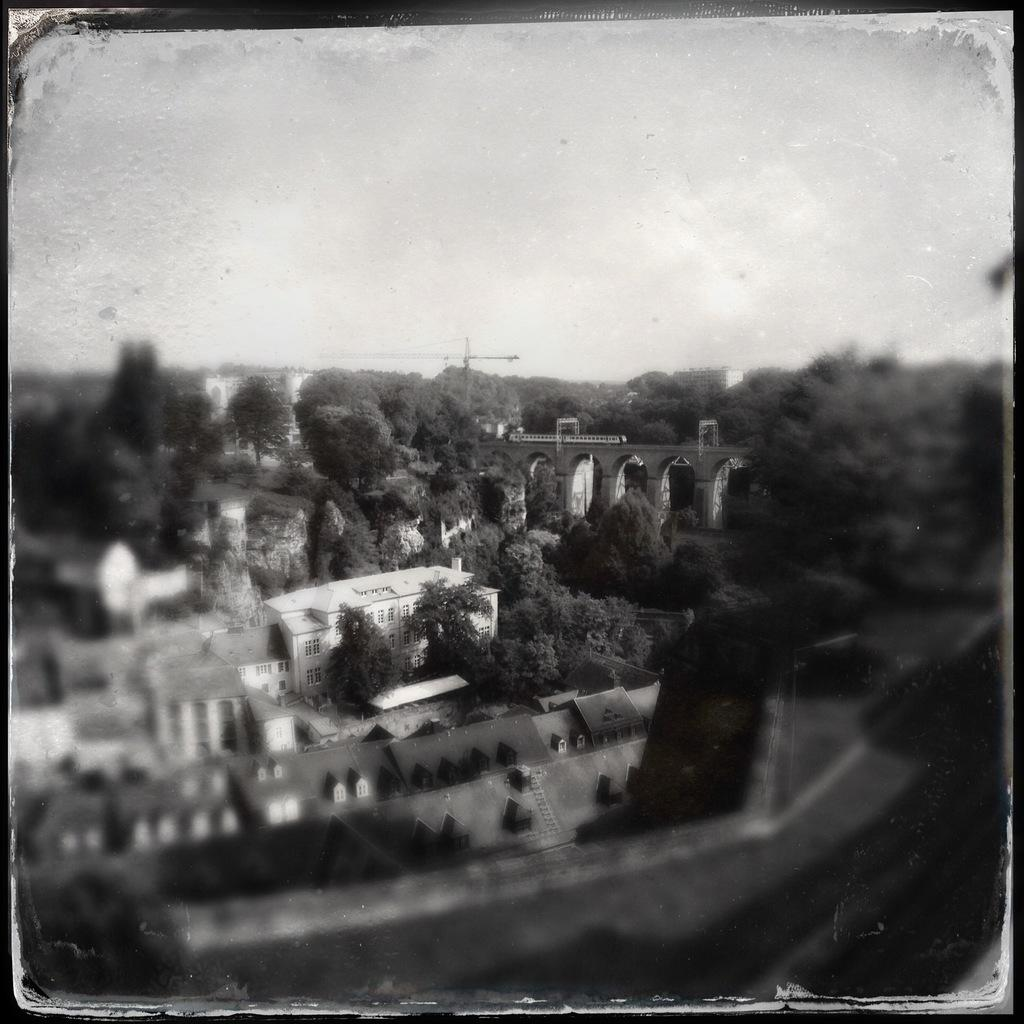What type of structures can be seen in the image? The image contains buildings. What type of vegetation is present in the image? There are trees in the image. What is visible at the top of the image? The sky is visible at the top of the image. What type of music can be heard coming from the buildings in the image? There is no indication of sound or music in the image, so it's not possible to determine what, if any, music might be heard. 